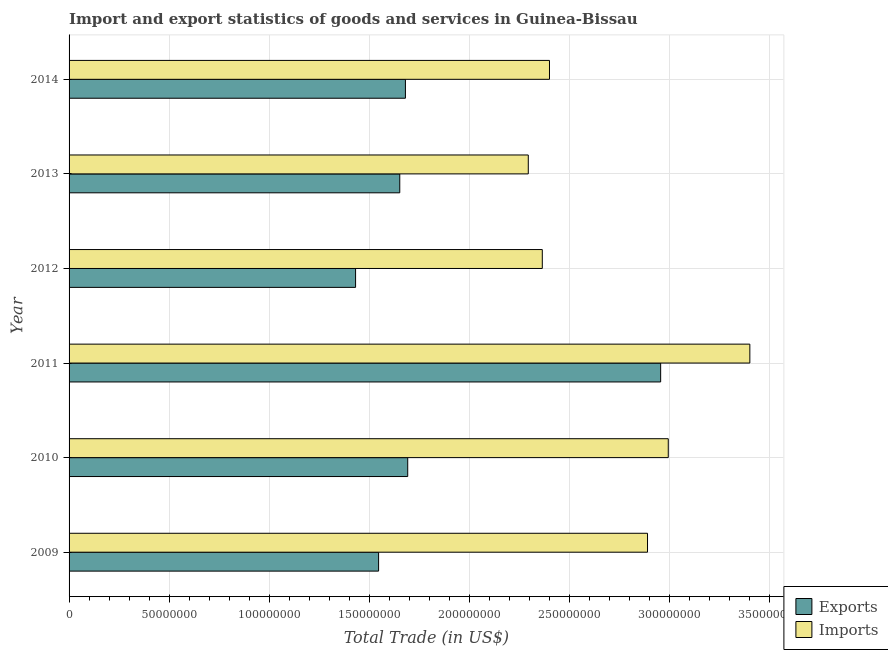How many different coloured bars are there?
Give a very brief answer. 2. How many groups of bars are there?
Your response must be concise. 6. How many bars are there on the 6th tick from the top?
Ensure brevity in your answer.  2. In how many cases, is the number of bars for a given year not equal to the number of legend labels?
Provide a succinct answer. 0. What is the export of goods and services in 2011?
Provide a succinct answer. 2.96e+08. Across all years, what is the maximum imports of goods and services?
Your answer should be compact. 3.40e+08. Across all years, what is the minimum imports of goods and services?
Keep it short and to the point. 2.30e+08. In which year was the export of goods and services maximum?
Ensure brevity in your answer.  2011. What is the total export of goods and services in the graph?
Give a very brief answer. 1.10e+09. What is the difference between the imports of goods and services in 2009 and that in 2014?
Give a very brief answer. 4.90e+07. What is the difference between the imports of goods and services in 2013 and the export of goods and services in 2010?
Your answer should be very brief. 6.03e+07. What is the average export of goods and services per year?
Ensure brevity in your answer.  1.83e+08. In the year 2011, what is the difference between the imports of goods and services and export of goods and services?
Your answer should be compact. 4.46e+07. What is the ratio of the imports of goods and services in 2013 to that in 2014?
Provide a short and direct response. 0.96. Is the difference between the export of goods and services in 2012 and 2014 greater than the difference between the imports of goods and services in 2012 and 2014?
Your response must be concise. No. What is the difference between the highest and the second highest imports of goods and services?
Offer a terse response. 4.08e+07. What is the difference between the highest and the lowest export of goods and services?
Your answer should be compact. 1.53e+08. Is the sum of the export of goods and services in 2010 and 2014 greater than the maximum imports of goods and services across all years?
Make the answer very short. No. What does the 2nd bar from the top in 2011 represents?
Make the answer very short. Exports. What does the 1st bar from the bottom in 2014 represents?
Keep it short and to the point. Exports. How many bars are there?
Make the answer very short. 12. Are all the bars in the graph horizontal?
Ensure brevity in your answer.  Yes. What is the difference between two consecutive major ticks on the X-axis?
Your answer should be compact. 5.00e+07. Are the values on the major ticks of X-axis written in scientific E-notation?
Your response must be concise. No. Does the graph contain any zero values?
Keep it short and to the point. No. Does the graph contain grids?
Your response must be concise. Yes. How many legend labels are there?
Offer a very short reply. 2. How are the legend labels stacked?
Your answer should be compact. Vertical. What is the title of the graph?
Provide a succinct answer. Import and export statistics of goods and services in Guinea-Bissau. Does "State government" appear as one of the legend labels in the graph?
Offer a very short reply. No. What is the label or title of the X-axis?
Make the answer very short. Total Trade (in US$). What is the label or title of the Y-axis?
Your response must be concise. Year. What is the Total Trade (in US$) of Exports in 2009?
Ensure brevity in your answer.  1.55e+08. What is the Total Trade (in US$) in Imports in 2009?
Your response must be concise. 2.89e+08. What is the Total Trade (in US$) of Exports in 2010?
Give a very brief answer. 1.69e+08. What is the Total Trade (in US$) of Imports in 2010?
Offer a terse response. 3.00e+08. What is the Total Trade (in US$) in Exports in 2011?
Offer a terse response. 2.96e+08. What is the Total Trade (in US$) in Imports in 2011?
Ensure brevity in your answer.  3.40e+08. What is the Total Trade (in US$) in Exports in 2012?
Ensure brevity in your answer.  1.43e+08. What is the Total Trade (in US$) of Imports in 2012?
Make the answer very short. 2.37e+08. What is the Total Trade (in US$) in Exports in 2013?
Offer a very short reply. 1.65e+08. What is the Total Trade (in US$) in Imports in 2013?
Provide a short and direct response. 2.30e+08. What is the Total Trade (in US$) in Exports in 2014?
Ensure brevity in your answer.  1.68e+08. What is the Total Trade (in US$) in Imports in 2014?
Give a very brief answer. 2.40e+08. Across all years, what is the maximum Total Trade (in US$) of Exports?
Your answer should be compact. 2.96e+08. Across all years, what is the maximum Total Trade (in US$) in Imports?
Your answer should be very brief. 3.40e+08. Across all years, what is the minimum Total Trade (in US$) in Exports?
Provide a short and direct response. 1.43e+08. Across all years, what is the minimum Total Trade (in US$) of Imports?
Keep it short and to the point. 2.30e+08. What is the total Total Trade (in US$) in Exports in the graph?
Provide a succinct answer. 1.10e+09. What is the total Total Trade (in US$) of Imports in the graph?
Your response must be concise. 1.64e+09. What is the difference between the Total Trade (in US$) in Exports in 2009 and that in 2010?
Give a very brief answer. -1.46e+07. What is the difference between the Total Trade (in US$) in Imports in 2009 and that in 2010?
Your answer should be compact. -1.04e+07. What is the difference between the Total Trade (in US$) of Exports in 2009 and that in 2011?
Your answer should be compact. -1.41e+08. What is the difference between the Total Trade (in US$) in Imports in 2009 and that in 2011?
Make the answer very short. -5.12e+07. What is the difference between the Total Trade (in US$) in Exports in 2009 and that in 2012?
Your answer should be compact. 1.15e+07. What is the difference between the Total Trade (in US$) of Imports in 2009 and that in 2012?
Keep it short and to the point. 5.26e+07. What is the difference between the Total Trade (in US$) of Exports in 2009 and that in 2013?
Your answer should be very brief. -1.06e+07. What is the difference between the Total Trade (in US$) in Imports in 2009 and that in 2013?
Provide a short and direct response. 5.96e+07. What is the difference between the Total Trade (in US$) of Exports in 2009 and that in 2014?
Keep it short and to the point. -1.34e+07. What is the difference between the Total Trade (in US$) of Imports in 2009 and that in 2014?
Ensure brevity in your answer.  4.90e+07. What is the difference between the Total Trade (in US$) in Exports in 2010 and that in 2011?
Offer a terse response. -1.26e+08. What is the difference between the Total Trade (in US$) of Imports in 2010 and that in 2011?
Offer a very short reply. -4.08e+07. What is the difference between the Total Trade (in US$) in Exports in 2010 and that in 2012?
Offer a terse response. 2.61e+07. What is the difference between the Total Trade (in US$) in Imports in 2010 and that in 2012?
Provide a short and direct response. 6.30e+07. What is the difference between the Total Trade (in US$) in Exports in 2010 and that in 2013?
Keep it short and to the point. 3.98e+06. What is the difference between the Total Trade (in US$) of Imports in 2010 and that in 2013?
Your answer should be very brief. 7.00e+07. What is the difference between the Total Trade (in US$) of Exports in 2010 and that in 2014?
Your response must be concise. 1.15e+06. What is the difference between the Total Trade (in US$) in Imports in 2010 and that in 2014?
Your answer should be compact. 5.94e+07. What is the difference between the Total Trade (in US$) of Exports in 2011 and that in 2012?
Offer a very short reply. 1.53e+08. What is the difference between the Total Trade (in US$) of Imports in 2011 and that in 2012?
Provide a succinct answer. 1.04e+08. What is the difference between the Total Trade (in US$) of Exports in 2011 and that in 2013?
Make the answer very short. 1.30e+08. What is the difference between the Total Trade (in US$) in Imports in 2011 and that in 2013?
Your answer should be very brief. 1.11e+08. What is the difference between the Total Trade (in US$) of Exports in 2011 and that in 2014?
Provide a short and direct response. 1.28e+08. What is the difference between the Total Trade (in US$) in Imports in 2011 and that in 2014?
Ensure brevity in your answer.  1.00e+08. What is the difference between the Total Trade (in US$) of Exports in 2012 and that in 2013?
Provide a short and direct response. -2.21e+07. What is the difference between the Total Trade (in US$) in Imports in 2012 and that in 2013?
Ensure brevity in your answer.  7.00e+06. What is the difference between the Total Trade (in US$) in Exports in 2012 and that in 2014?
Your answer should be compact. -2.49e+07. What is the difference between the Total Trade (in US$) in Imports in 2012 and that in 2014?
Make the answer very short. -3.59e+06. What is the difference between the Total Trade (in US$) in Exports in 2013 and that in 2014?
Keep it short and to the point. -2.83e+06. What is the difference between the Total Trade (in US$) in Imports in 2013 and that in 2014?
Ensure brevity in your answer.  -1.06e+07. What is the difference between the Total Trade (in US$) of Exports in 2009 and the Total Trade (in US$) of Imports in 2010?
Provide a short and direct response. -1.45e+08. What is the difference between the Total Trade (in US$) in Exports in 2009 and the Total Trade (in US$) in Imports in 2011?
Offer a terse response. -1.86e+08. What is the difference between the Total Trade (in US$) in Exports in 2009 and the Total Trade (in US$) in Imports in 2012?
Your answer should be very brief. -8.18e+07. What is the difference between the Total Trade (in US$) of Exports in 2009 and the Total Trade (in US$) of Imports in 2013?
Provide a short and direct response. -7.48e+07. What is the difference between the Total Trade (in US$) in Exports in 2009 and the Total Trade (in US$) in Imports in 2014?
Provide a succinct answer. -8.54e+07. What is the difference between the Total Trade (in US$) of Exports in 2010 and the Total Trade (in US$) of Imports in 2011?
Offer a very short reply. -1.71e+08. What is the difference between the Total Trade (in US$) in Exports in 2010 and the Total Trade (in US$) in Imports in 2012?
Your response must be concise. -6.73e+07. What is the difference between the Total Trade (in US$) in Exports in 2010 and the Total Trade (in US$) in Imports in 2013?
Your answer should be very brief. -6.03e+07. What is the difference between the Total Trade (in US$) in Exports in 2010 and the Total Trade (in US$) in Imports in 2014?
Provide a short and direct response. -7.09e+07. What is the difference between the Total Trade (in US$) of Exports in 2011 and the Total Trade (in US$) of Imports in 2012?
Your answer should be compact. 5.92e+07. What is the difference between the Total Trade (in US$) in Exports in 2011 and the Total Trade (in US$) in Imports in 2013?
Give a very brief answer. 6.62e+07. What is the difference between the Total Trade (in US$) of Exports in 2011 and the Total Trade (in US$) of Imports in 2014?
Your answer should be compact. 5.56e+07. What is the difference between the Total Trade (in US$) of Exports in 2012 and the Total Trade (in US$) of Imports in 2013?
Your answer should be compact. -8.64e+07. What is the difference between the Total Trade (in US$) in Exports in 2012 and the Total Trade (in US$) in Imports in 2014?
Ensure brevity in your answer.  -9.69e+07. What is the difference between the Total Trade (in US$) of Exports in 2013 and the Total Trade (in US$) of Imports in 2014?
Provide a short and direct response. -7.49e+07. What is the average Total Trade (in US$) in Exports per year?
Offer a terse response. 1.83e+08. What is the average Total Trade (in US$) in Imports per year?
Your answer should be compact. 2.73e+08. In the year 2009, what is the difference between the Total Trade (in US$) in Exports and Total Trade (in US$) in Imports?
Keep it short and to the point. -1.34e+08. In the year 2010, what is the difference between the Total Trade (in US$) in Exports and Total Trade (in US$) in Imports?
Your answer should be compact. -1.30e+08. In the year 2011, what is the difference between the Total Trade (in US$) of Exports and Total Trade (in US$) of Imports?
Give a very brief answer. -4.46e+07. In the year 2012, what is the difference between the Total Trade (in US$) of Exports and Total Trade (in US$) of Imports?
Provide a succinct answer. -9.34e+07. In the year 2013, what is the difference between the Total Trade (in US$) in Exports and Total Trade (in US$) in Imports?
Provide a succinct answer. -6.43e+07. In the year 2014, what is the difference between the Total Trade (in US$) of Exports and Total Trade (in US$) of Imports?
Provide a succinct answer. -7.20e+07. What is the ratio of the Total Trade (in US$) in Exports in 2009 to that in 2010?
Give a very brief answer. 0.91. What is the ratio of the Total Trade (in US$) in Imports in 2009 to that in 2010?
Ensure brevity in your answer.  0.97. What is the ratio of the Total Trade (in US$) in Exports in 2009 to that in 2011?
Keep it short and to the point. 0.52. What is the ratio of the Total Trade (in US$) of Imports in 2009 to that in 2011?
Offer a terse response. 0.85. What is the ratio of the Total Trade (in US$) in Exports in 2009 to that in 2012?
Keep it short and to the point. 1.08. What is the ratio of the Total Trade (in US$) of Imports in 2009 to that in 2012?
Ensure brevity in your answer.  1.22. What is the ratio of the Total Trade (in US$) of Exports in 2009 to that in 2013?
Your answer should be very brief. 0.94. What is the ratio of the Total Trade (in US$) of Imports in 2009 to that in 2013?
Offer a very short reply. 1.26. What is the ratio of the Total Trade (in US$) of Exports in 2009 to that in 2014?
Give a very brief answer. 0.92. What is the ratio of the Total Trade (in US$) in Imports in 2009 to that in 2014?
Ensure brevity in your answer.  1.2. What is the ratio of the Total Trade (in US$) of Exports in 2010 to that in 2011?
Your response must be concise. 0.57. What is the ratio of the Total Trade (in US$) in Imports in 2010 to that in 2011?
Make the answer very short. 0.88. What is the ratio of the Total Trade (in US$) in Exports in 2010 to that in 2012?
Offer a terse response. 1.18. What is the ratio of the Total Trade (in US$) in Imports in 2010 to that in 2012?
Your answer should be very brief. 1.27. What is the ratio of the Total Trade (in US$) of Exports in 2010 to that in 2013?
Make the answer very short. 1.02. What is the ratio of the Total Trade (in US$) of Imports in 2010 to that in 2013?
Your answer should be compact. 1.3. What is the ratio of the Total Trade (in US$) in Exports in 2010 to that in 2014?
Offer a very short reply. 1.01. What is the ratio of the Total Trade (in US$) of Imports in 2010 to that in 2014?
Provide a short and direct response. 1.25. What is the ratio of the Total Trade (in US$) of Exports in 2011 to that in 2012?
Offer a terse response. 2.06. What is the ratio of the Total Trade (in US$) of Imports in 2011 to that in 2012?
Provide a succinct answer. 1.44. What is the ratio of the Total Trade (in US$) of Exports in 2011 to that in 2013?
Your answer should be very brief. 1.79. What is the ratio of the Total Trade (in US$) of Imports in 2011 to that in 2013?
Keep it short and to the point. 1.48. What is the ratio of the Total Trade (in US$) in Exports in 2011 to that in 2014?
Your answer should be very brief. 1.76. What is the ratio of the Total Trade (in US$) of Imports in 2011 to that in 2014?
Your answer should be very brief. 1.42. What is the ratio of the Total Trade (in US$) of Exports in 2012 to that in 2013?
Give a very brief answer. 0.87. What is the ratio of the Total Trade (in US$) of Imports in 2012 to that in 2013?
Make the answer very short. 1.03. What is the ratio of the Total Trade (in US$) of Exports in 2012 to that in 2014?
Provide a short and direct response. 0.85. What is the ratio of the Total Trade (in US$) in Imports in 2012 to that in 2014?
Your answer should be very brief. 0.98. What is the ratio of the Total Trade (in US$) of Exports in 2013 to that in 2014?
Provide a short and direct response. 0.98. What is the ratio of the Total Trade (in US$) in Imports in 2013 to that in 2014?
Your answer should be compact. 0.96. What is the difference between the highest and the second highest Total Trade (in US$) of Exports?
Make the answer very short. 1.26e+08. What is the difference between the highest and the second highest Total Trade (in US$) in Imports?
Keep it short and to the point. 4.08e+07. What is the difference between the highest and the lowest Total Trade (in US$) in Exports?
Offer a terse response. 1.53e+08. What is the difference between the highest and the lowest Total Trade (in US$) in Imports?
Provide a short and direct response. 1.11e+08. 